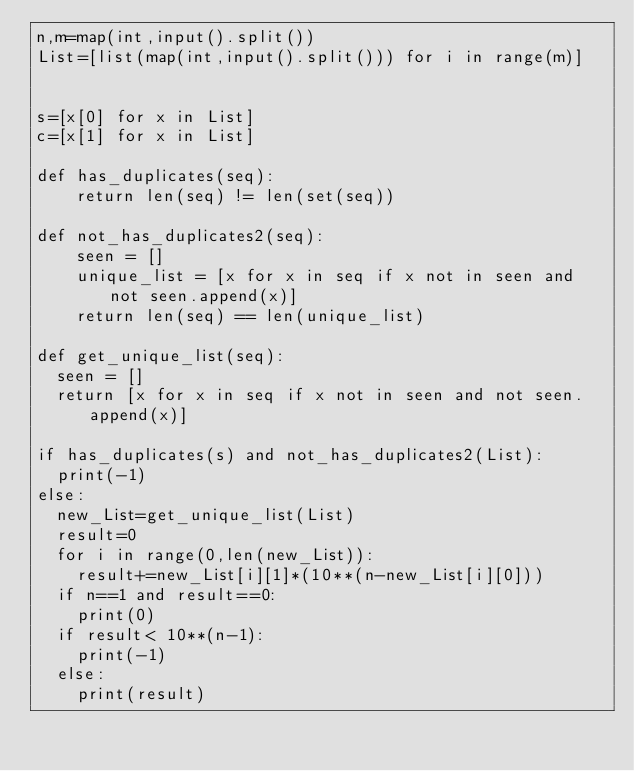Convert code to text. <code><loc_0><loc_0><loc_500><loc_500><_Python_>n,m=map(int,input().split())
List=[list(map(int,input().split())) for i in range(m)]


s=[x[0] for x in List]
c=[x[1] for x in List]

def has_duplicates(seq):
    return len(seq) != len(set(seq))

def not_has_duplicates2(seq):
    seen = []
    unique_list = [x for x in seq if x not in seen and not seen.append(x)]
    return len(seq) == len(unique_list)

def get_unique_list(seq):
  seen = []
  return [x for x in seq if x not in seen and not seen.append(x)]
  
if has_duplicates(s) and not_has_duplicates2(List):
  print(-1)
else:
  new_List=get_unique_list(List)
  result=0
  for i in range(0,len(new_List)):
    result+=new_List[i][1]*(10**(n-new_List[i][0]))
  if n==1 and result==0:
    print(0)
  if result< 10**(n-1):
    print(-1)
  else:
    print(result)
    </code> 